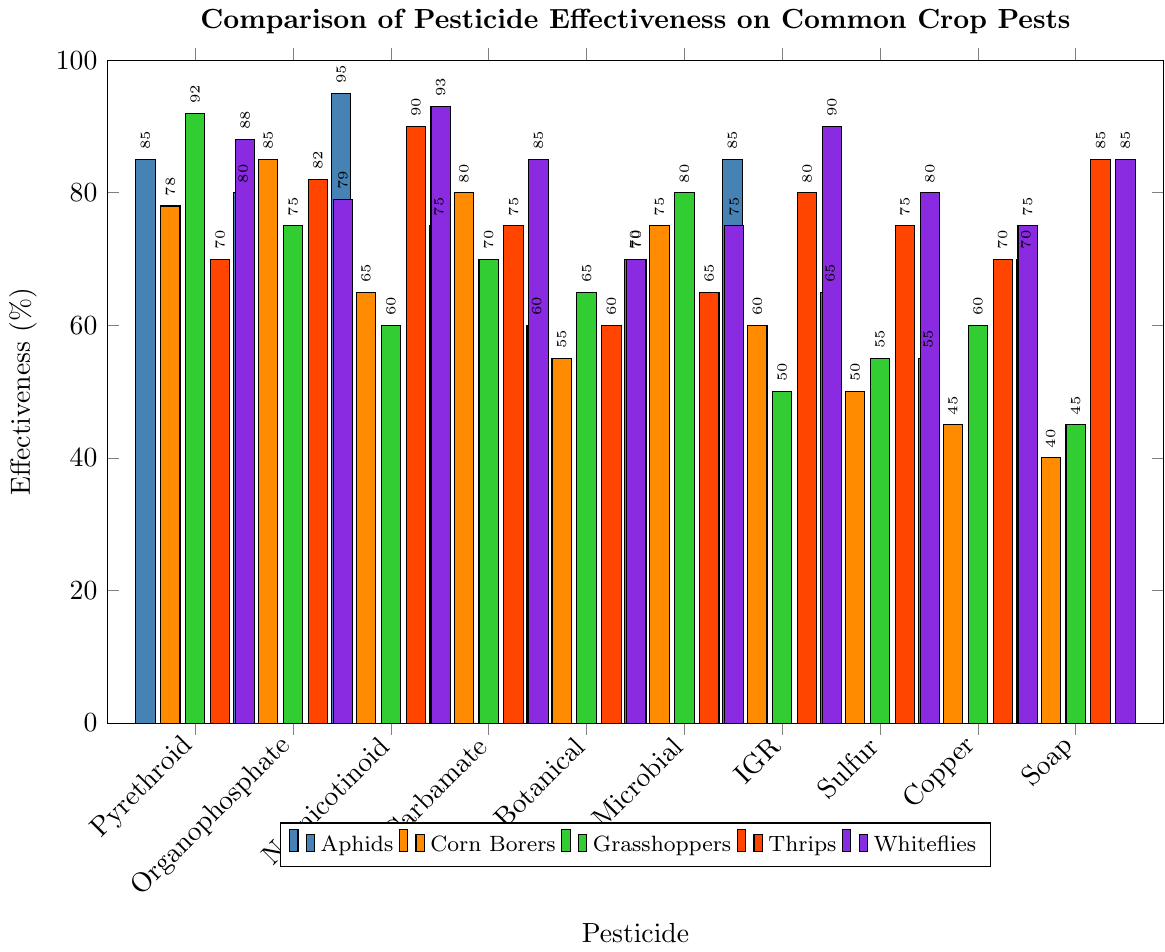What is the most effective pesticide against Aphids? By examining the bar heights in the Aphids category, the tallest bar represents the most effective pesticide. The tallest bar corresponds to Neonicotinoid with 95% effectiveness.
Answer: Neonicotinoid Which pesticide is the least effective against Grasshoppers? By examining the bar heights in the Grasshoppers category, the shortest bar represents the least effective pesticide. The shortest bar corresponds to Soap-based with 45% effectiveness.
Answer: Soap-based What is the average effectiveness of Organophosphate against all pests? Sum the effectiveness values for Organophosphate (80 for Aphids, 85 for Corn Borers, 75 for Grasshoppers, 82 for Thrips, 79 for Whiteflies) and divide by the number of pest types (5). (80+85+75+82+79)/5 = 80.2
Answer: 80.2 Compare the effectiveness of Botanical pesticides against Corn Borers and Grasshoppers. Locate the bar heights of Botanical against Corn Borers and Grasshoppers. Botanical's effectiveness is 55% for Corn Borers and 65% for Grasshoppers. Grasshoppers' effectiveness is higher.
Answer: Grasshoppers Which pesticide has the highest overall effectiveness against Thrips? Looking at the bar heights in the Thrips category, the tallest bar indicates the highest effectiveness. The tallest bar corresponds to Soap-based with 85% effectiveness.
Answer: Soap-based Is Pyrethroid more effective against Whiteflies or Corn Borers? Compare the bar heights of Pyrethroid for Whiteflies and Corn Borers. Pyrethroid's effectiveness is 88% for Whiteflies and 78% for Corn Borers. Whiteflies' effectiveness is higher.
Answer: Whiteflies What is the total effectiveness of Microbial pesticides against all pest types combined? Sum the effectiveness values for Microbial across all pests (70 for Aphids, 75 for Corn Borers, 80 for Grasshoppers, 65 for Thrips, 75 for Whiteflies). 70+75+80+65+75 = 365
Answer: 365 Which group of pests shows the widest range of effectiveness values across different pesticides? Calculate the difference between the highest and lowest effectiveness values for each pest type and compare them. Corn Borers range: 85-40=45, Aphids range: 95-55=40, Grasshoppers range: 92-45=47, Thrips range: 90-70=20, Whiteflies range: 93-75=18. Grasshoppers have the widest range with 47.
Answer: Grasshoppers 